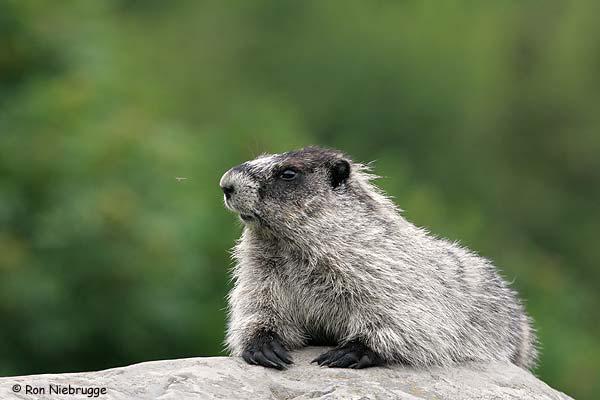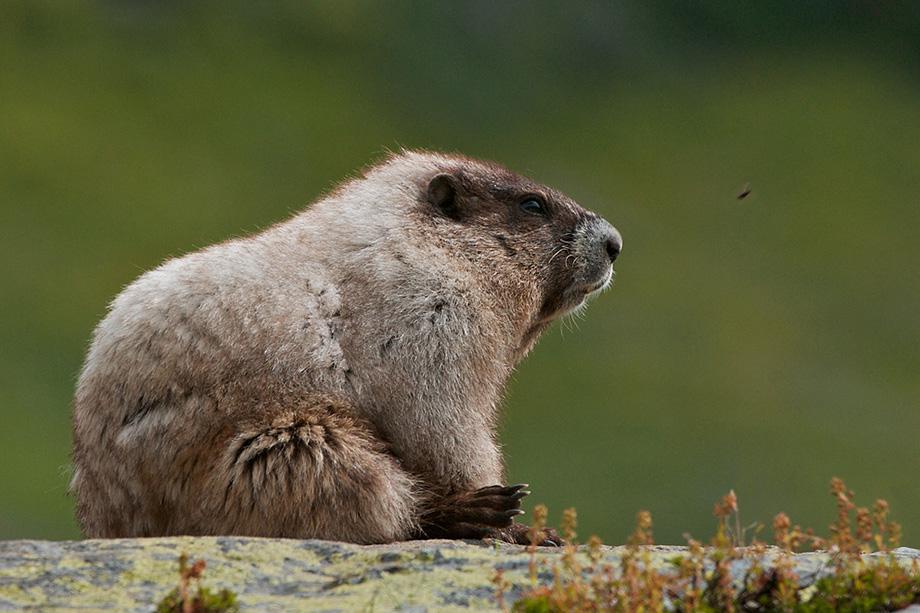The first image is the image on the left, the second image is the image on the right. Given the left and right images, does the statement "The left and right image contains the same number of groundhogs on stone.." hold true? Answer yes or no. Yes. The first image is the image on the left, the second image is the image on the right. Assess this claim about the two images: "There are two marmots on rocks.". Correct or not? Answer yes or no. Yes. 